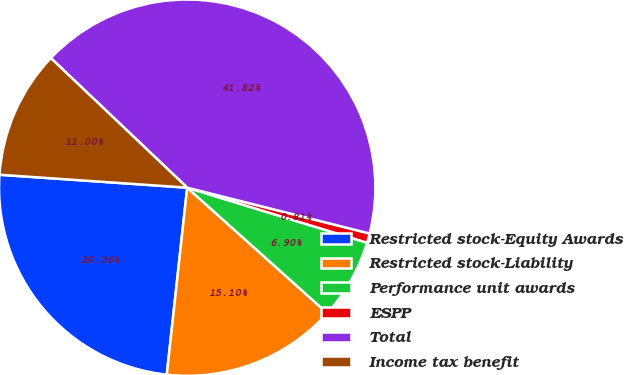Convert chart to OTSL. <chart><loc_0><loc_0><loc_500><loc_500><pie_chart><fcel>Restricted stock-Equity Awards<fcel>Restricted stock-Liability<fcel>Performance unit awards<fcel>ESPP<fcel>Total<fcel>Income tax benefit<nl><fcel>24.36%<fcel>15.1%<fcel>6.9%<fcel>0.81%<fcel>41.82%<fcel>11.0%<nl></chart> 